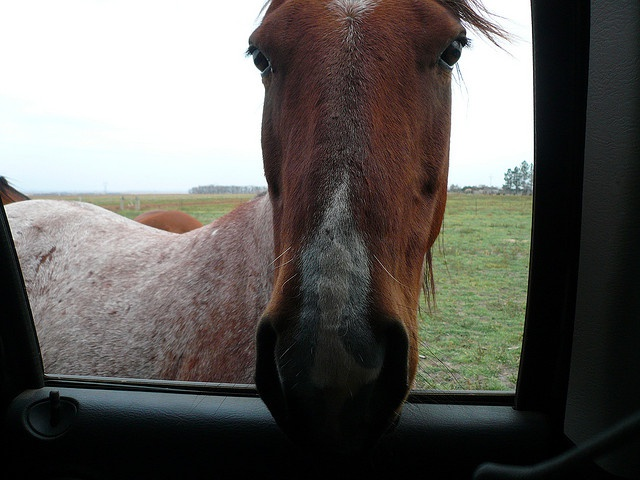Describe the objects in this image and their specific colors. I can see horse in white, black, maroon, gray, and darkgray tones and horse in white, brown, lightgray, and tan tones in this image. 